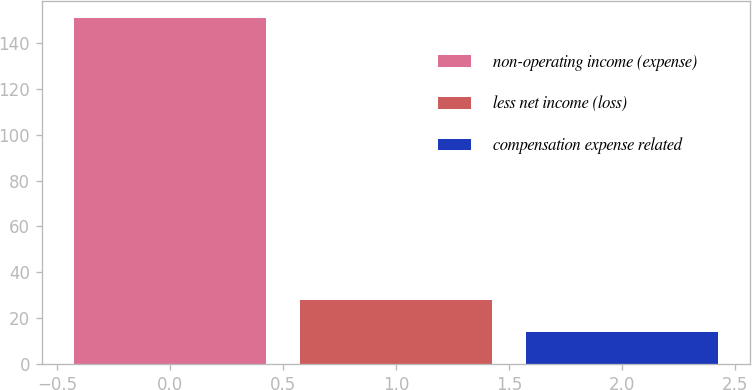<chart> <loc_0><loc_0><loc_500><loc_500><bar_chart><fcel>non-operating income (expense)<fcel>less net income (loss)<fcel>compensation expense related<nl><fcel>150.8<fcel>27.8<fcel>14<nl></chart> 